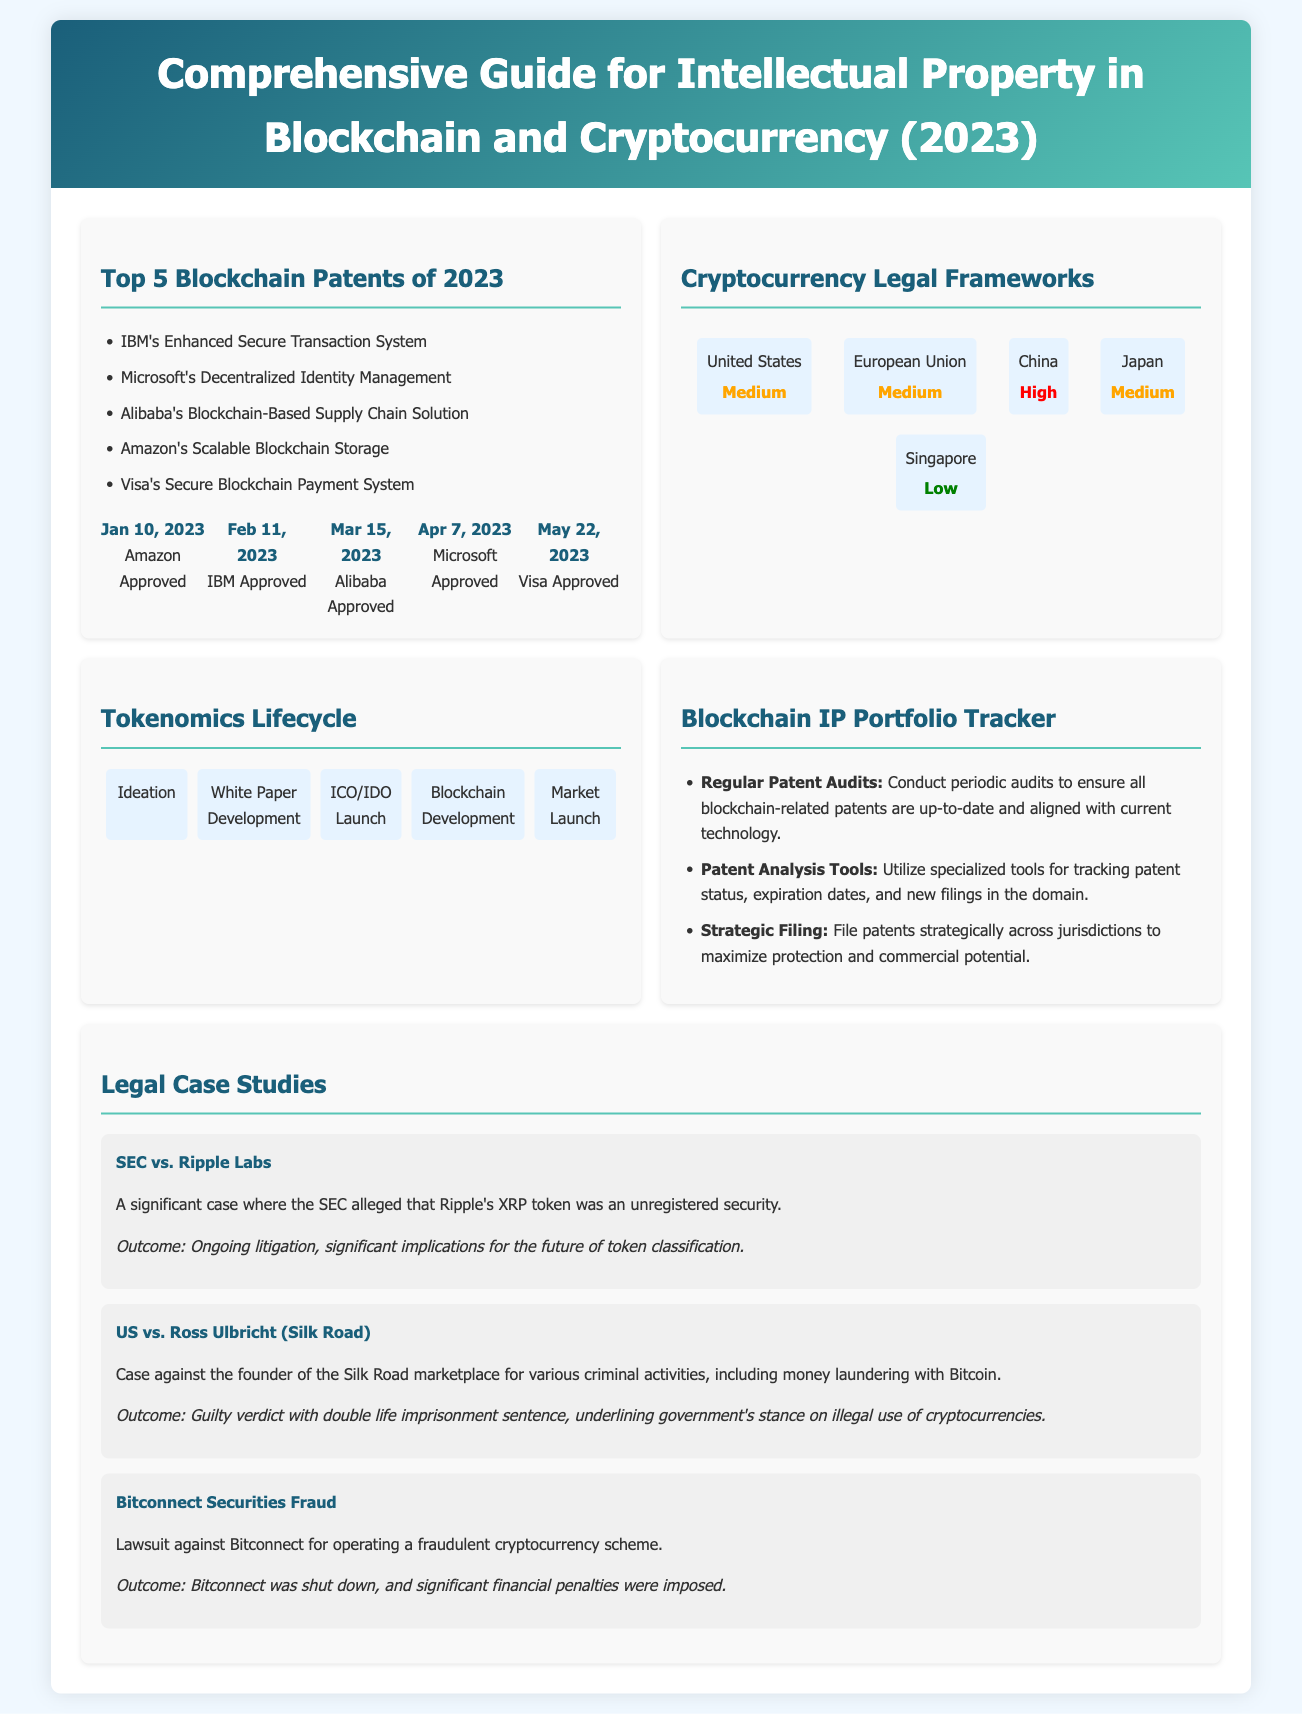what is the first blockchain patent approved in 2023? The document lists Amazon's patent as the first approved on January 10, 2023.
Answer: Amazon's Enhanced Secure Transaction System which company filed a patent for Decentralized Identity Management? The document states that Microsoft filed a patent for this system.
Answer: Microsoft what is the severity level of the regulatory framework in China? The map indicates that the severity level of the regulatory framework in China is classified as High.
Answer: High how many phases are there in the Tokenomics Lifecycle? The Tokenomics Lifecycle is divided into five phases as outlined in the document.
Answer: Five what was the outcome of the SEC vs. Ripple Labs case? The document mentions that this case is ongoing and has significant implications for token classification.
Answer: Ongoing litigation which blockchain patent was approved on May 22, 2023? The document states that Visa's patent was approved on this date.
Answer: Visa's Secure Blockchain Payment System what are the three best practices mentioned for maintaining a digital asset patent portfolio? The best practices listed are regular patent audits, patent analysis tools, and strategic filing.
Answer: Regular patent audits, patent analysis tools, strategic filing how many landmark court decisions are summarized in the document? The document presents three notable legal case studies related to blockchain and cryptocurrency law.
Answer: Three 